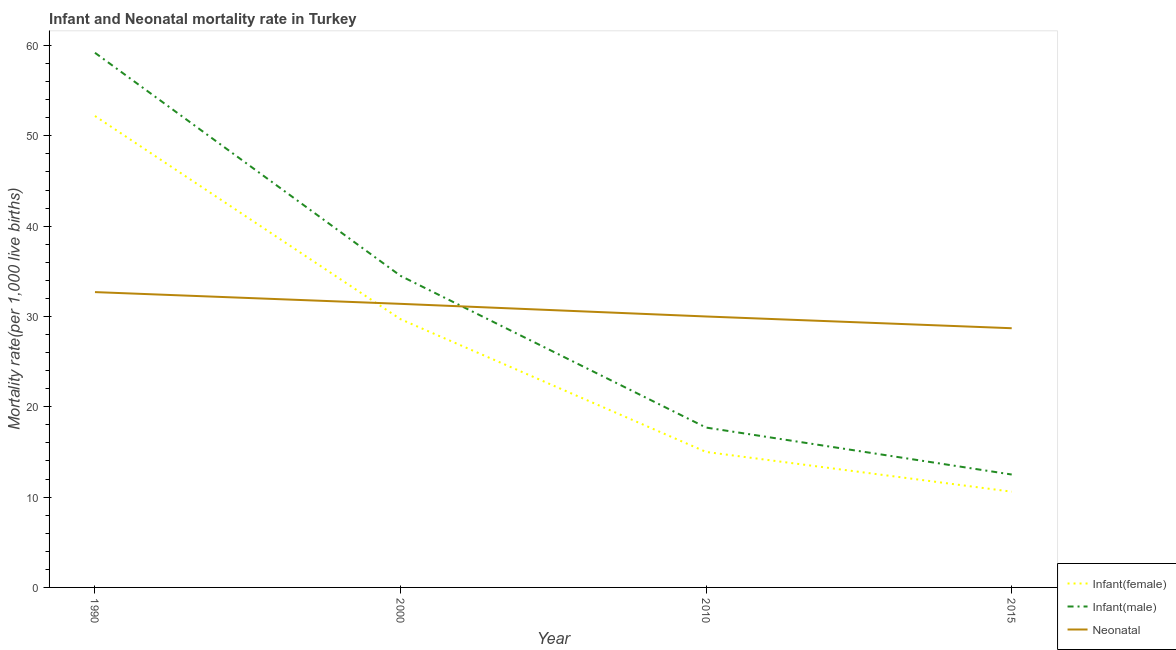How many different coloured lines are there?
Your response must be concise. 3. Is the number of lines equal to the number of legend labels?
Offer a very short reply. Yes. What is the infant mortality rate(male) in 2010?
Offer a terse response. 17.7. Across all years, what is the maximum infant mortality rate(male)?
Offer a very short reply. 59.2. Across all years, what is the minimum neonatal mortality rate?
Your answer should be compact. 28.7. In which year was the infant mortality rate(male) minimum?
Offer a terse response. 2015. What is the total neonatal mortality rate in the graph?
Offer a terse response. 122.8. What is the difference between the infant mortality rate(female) in 2010 and that in 2015?
Your answer should be very brief. 4.4. What is the difference between the infant mortality rate(female) in 2010 and the infant mortality rate(male) in 1990?
Give a very brief answer. -44.2. What is the average infant mortality rate(male) per year?
Keep it short and to the point. 30.98. What is the ratio of the infant mortality rate(female) in 2000 to that in 2010?
Provide a succinct answer. 1.98. What is the difference between the highest and the second highest neonatal mortality rate?
Offer a very short reply. 1.3. What is the difference between the highest and the lowest infant mortality rate(male)?
Ensure brevity in your answer.  46.7. Is the sum of the neonatal mortality rate in 1990 and 2000 greater than the maximum infant mortality rate(male) across all years?
Your answer should be very brief. Yes. Is the neonatal mortality rate strictly less than the infant mortality rate(female) over the years?
Provide a short and direct response. No. How many lines are there?
Provide a short and direct response. 3. How many years are there in the graph?
Give a very brief answer. 4. What is the difference between two consecutive major ticks on the Y-axis?
Your answer should be compact. 10. Does the graph contain grids?
Your response must be concise. No. Where does the legend appear in the graph?
Offer a terse response. Bottom right. What is the title of the graph?
Offer a terse response. Infant and Neonatal mortality rate in Turkey. Does "Slovak Republic" appear as one of the legend labels in the graph?
Provide a short and direct response. No. What is the label or title of the X-axis?
Ensure brevity in your answer.  Year. What is the label or title of the Y-axis?
Your answer should be compact. Mortality rate(per 1,0 live births). What is the Mortality rate(per 1,000 live births) in Infant(female) in 1990?
Provide a succinct answer. 52.2. What is the Mortality rate(per 1,000 live births) of Infant(male) in 1990?
Offer a terse response. 59.2. What is the Mortality rate(per 1,000 live births) of Neonatal  in 1990?
Your response must be concise. 32.7. What is the Mortality rate(per 1,000 live births) of Infant(female) in 2000?
Keep it short and to the point. 29.7. What is the Mortality rate(per 1,000 live births) of Infant(male) in 2000?
Give a very brief answer. 34.5. What is the Mortality rate(per 1,000 live births) in Neonatal  in 2000?
Offer a very short reply. 31.4. What is the Mortality rate(per 1,000 live births) of Infant(male) in 2010?
Keep it short and to the point. 17.7. What is the Mortality rate(per 1,000 live births) in Neonatal  in 2010?
Your response must be concise. 30. What is the Mortality rate(per 1,000 live births) of Infant(female) in 2015?
Ensure brevity in your answer.  10.6. What is the Mortality rate(per 1,000 live births) of Neonatal  in 2015?
Offer a terse response. 28.7. Across all years, what is the maximum Mortality rate(per 1,000 live births) of Infant(female)?
Give a very brief answer. 52.2. Across all years, what is the maximum Mortality rate(per 1,000 live births) of Infant(male)?
Provide a succinct answer. 59.2. Across all years, what is the maximum Mortality rate(per 1,000 live births) in Neonatal ?
Your answer should be very brief. 32.7. Across all years, what is the minimum Mortality rate(per 1,000 live births) in Infant(female)?
Your answer should be very brief. 10.6. Across all years, what is the minimum Mortality rate(per 1,000 live births) of Neonatal ?
Give a very brief answer. 28.7. What is the total Mortality rate(per 1,000 live births) in Infant(female) in the graph?
Ensure brevity in your answer.  107.5. What is the total Mortality rate(per 1,000 live births) in Infant(male) in the graph?
Offer a terse response. 123.9. What is the total Mortality rate(per 1,000 live births) in Neonatal  in the graph?
Make the answer very short. 122.8. What is the difference between the Mortality rate(per 1,000 live births) in Infant(male) in 1990 and that in 2000?
Give a very brief answer. 24.7. What is the difference between the Mortality rate(per 1,000 live births) in Neonatal  in 1990 and that in 2000?
Your answer should be compact. 1.3. What is the difference between the Mortality rate(per 1,000 live births) of Infant(female) in 1990 and that in 2010?
Offer a terse response. 37.2. What is the difference between the Mortality rate(per 1,000 live births) in Infant(male) in 1990 and that in 2010?
Make the answer very short. 41.5. What is the difference between the Mortality rate(per 1,000 live births) in Neonatal  in 1990 and that in 2010?
Your response must be concise. 2.7. What is the difference between the Mortality rate(per 1,000 live births) of Infant(female) in 1990 and that in 2015?
Provide a short and direct response. 41.6. What is the difference between the Mortality rate(per 1,000 live births) of Infant(male) in 1990 and that in 2015?
Ensure brevity in your answer.  46.7. What is the difference between the Mortality rate(per 1,000 live births) of Infant(male) in 2000 and that in 2010?
Give a very brief answer. 16.8. What is the difference between the Mortality rate(per 1,000 live births) of Infant(female) in 2000 and that in 2015?
Your answer should be very brief. 19.1. What is the difference between the Mortality rate(per 1,000 live births) in Infant(male) in 2010 and that in 2015?
Give a very brief answer. 5.2. What is the difference between the Mortality rate(per 1,000 live births) of Neonatal  in 2010 and that in 2015?
Make the answer very short. 1.3. What is the difference between the Mortality rate(per 1,000 live births) in Infant(female) in 1990 and the Mortality rate(per 1,000 live births) in Neonatal  in 2000?
Provide a succinct answer. 20.8. What is the difference between the Mortality rate(per 1,000 live births) in Infant(male) in 1990 and the Mortality rate(per 1,000 live births) in Neonatal  in 2000?
Your answer should be compact. 27.8. What is the difference between the Mortality rate(per 1,000 live births) of Infant(female) in 1990 and the Mortality rate(per 1,000 live births) of Infant(male) in 2010?
Your answer should be very brief. 34.5. What is the difference between the Mortality rate(per 1,000 live births) of Infant(male) in 1990 and the Mortality rate(per 1,000 live births) of Neonatal  in 2010?
Your answer should be very brief. 29.2. What is the difference between the Mortality rate(per 1,000 live births) in Infant(female) in 1990 and the Mortality rate(per 1,000 live births) in Infant(male) in 2015?
Give a very brief answer. 39.7. What is the difference between the Mortality rate(per 1,000 live births) of Infant(female) in 1990 and the Mortality rate(per 1,000 live births) of Neonatal  in 2015?
Your response must be concise. 23.5. What is the difference between the Mortality rate(per 1,000 live births) in Infant(male) in 1990 and the Mortality rate(per 1,000 live births) in Neonatal  in 2015?
Provide a succinct answer. 30.5. What is the difference between the Mortality rate(per 1,000 live births) in Infant(female) in 2000 and the Mortality rate(per 1,000 live births) in Infant(male) in 2010?
Provide a succinct answer. 12. What is the difference between the Mortality rate(per 1,000 live births) in Infant(female) in 2000 and the Mortality rate(per 1,000 live births) in Neonatal  in 2010?
Give a very brief answer. -0.3. What is the difference between the Mortality rate(per 1,000 live births) in Infant(female) in 2000 and the Mortality rate(per 1,000 live births) in Infant(male) in 2015?
Your answer should be very brief. 17.2. What is the difference between the Mortality rate(per 1,000 live births) in Infant(female) in 2010 and the Mortality rate(per 1,000 live births) in Infant(male) in 2015?
Ensure brevity in your answer.  2.5. What is the difference between the Mortality rate(per 1,000 live births) of Infant(female) in 2010 and the Mortality rate(per 1,000 live births) of Neonatal  in 2015?
Your response must be concise. -13.7. What is the difference between the Mortality rate(per 1,000 live births) in Infant(male) in 2010 and the Mortality rate(per 1,000 live births) in Neonatal  in 2015?
Provide a succinct answer. -11. What is the average Mortality rate(per 1,000 live births) in Infant(female) per year?
Keep it short and to the point. 26.88. What is the average Mortality rate(per 1,000 live births) of Infant(male) per year?
Offer a very short reply. 30.98. What is the average Mortality rate(per 1,000 live births) in Neonatal  per year?
Provide a short and direct response. 30.7. In the year 1990, what is the difference between the Mortality rate(per 1,000 live births) of Infant(female) and Mortality rate(per 1,000 live births) of Neonatal ?
Your answer should be very brief. 19.5. In the year 2000, what is the difference between the Mortality rate(per 1,000 live births) of Infant(female) and Mortality rate(per 1,000 live births) of Neonatal ?
Your answer should be compact. -1.7. In the year 2000, what is the difference between the Mortality rate(per 1,000 live births) in Infant(male) and Mortality rate(per 1,000 live births) in Neonatal ?
Make the answer very short. 3.1. In the year 2010, what is the difference between the Mortality rate(per 1,000 live births) in Infant(female) and Mortality rate(per 1,000 live births) in Infant(male)?
Keep it short and to the point. -2.7. In the year 2015, what is the difference between the Mortality rate(per 1,000 live births) in Infant(female) and Mortality rate(per 1,000 live births) in Neonatal ?
Offer a very short reply. -18.1. In the year 2015, what is the difference between the Mortality rate(per 1,000 live births) in Infant(male) and Mortality rate(per 1,000 live births) in Neonatal ?
Make the answer very short. -16.2. What is the ratio of the Mortality rate(per 1,000 live births) of Infant(female) in 1990 to that in 2000?
Provide a short and direct response. 1.76. What is the ratio of the Mortality rate(per 1,000 live births) in Infant(male) in 1990 to that in 2000?
Your answer should be compact. 1.72. What is the ratio of the Mortality rate(per 1,000 live births) of Neonatal  in 1990 to that in 2000?
Ensure brevity in your answer.  1.04. What is the ratio of the Mortality rate(per 1,000 live births) of Infant(female) in 1990 to that in 2010?
Your answer should be compact. 3.48. What is the ratio of the Mortality rate(per 1,000 live births) in Infant(male) in 1990 to that in 2010?
Offer a terse response. 3.34. What is the ratio of the Mortality rate(per 1,000 live births) of Neonatal  in 1990 to that in 2010?
Keep it short and to the point. 1.09. What is the ratio of the Mortality rate(per 1,000 live births) in Infant(female) in 1990 to that in 2015?
Make the answer very short. 4.92. What is the ratio of the Mortality rate(per 1,000 live births) of Infant(male) in 1990 to that in 2015?
Your answer should be very brief. 4.74. What is the ratio of the Mortality rate(per 1,000 live births) in Neonatal  in 1990 to that in 2015?
Your response must be concise. 1.14. What is the ratio of the Mortality rate(per 1,000 live births) in Infant(female) in 2000 to that in 2010?
Provide a succinct answer. 1.98. What is the ratio of the Mortality rate(per 1,000 live births) of Infant(male) in 2000 to that in 2010?
Provide a succinct answer. 1.95. What is the ratio of the Mortality rate(per 1,000 live births) in Neonatal  in 2000 to that in 2010?
Keep it short and to the point. 1.05. What is the ratio of the Mortality rate(per 1,000 live births) in Infant(female) in 2000 to that in 2015?
Make the answer very short. 2.8. What is the ratio of the Mortality rate(per 1,000 live births) of Infant(male) in 2000 to that in 2015?
Ensure brevity in your answer.  2.76. What is the ratio of the Mortality rate(per 1,000 live births) of Neonatal  in 2000 to that in 2015?
Your answer should be compact. 1.09. What is the ratio of the Mortality rate(per 1,000 live births) of Infant(female) in 2010 to that in 2015?
Offer a terse response. 1.42. What is the ratio of the Mortality rate(per 1,000 live births) of Infant(male) in 2010 to that in 2015?
Give a very brief answer. 1.42. What is the ratio of the Mortality rate(per 1,000 live births) of Neonatal  in 2010 to that in 2015?
Your response must be concise. 1.05. What is the difference between the highest and the second highest Mortality rate(per 1,000 live births) of Infant(female)?
Your answer should be compact. 22.5. What is the difference between the highest and the second highest Mortality rate(per 1,000 live births) in Infant(male)?
Provide a short and direct response. 24.7. What is the difference between the highest and the second highest Mortality rate(per 1,000 live births) of Neonatal ?
Your answer should be very brief. 1.3. What is the difference between the highest and the lowest Mortality rate(per 1,000 live births) in Infant(female)?
Offer a terse response. 41.6. What is the difference between the highest and the lowest Mortality rate(per 1,000 live births) of Infant(male)?
Your answer should be compact. 46.7. What is the difference between the highest and the lowest Mortality rate(per 1,000 live births) of Neonatal ?
Offer a very short reply. 4. 